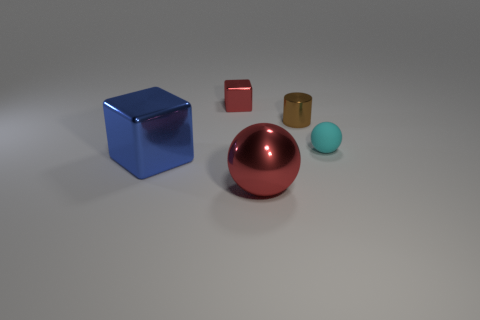There is a large blue metal object; is it the same shape as the red thing that is behind the cyan object?
Offer a terse response. Yes. There is a thing that is the same color as the metallic ball; what is its shape?
Offer a very short reply. Cube. Is the number of large blue blocks right of the big red ball less than the number of large cyan matte things?
Make the answer very short. No. Is the shape of the small matte thing the same as the big red object?
Your answer should be compact. Yes. The blue cube that is the same material as the big red object is what size?
Your response must be concise. Large. Are there fewer brown matte balls than large spheres?
Your answer should be compact. Yes. How many tiny things are green metallic cylinders or red metallic things?
Make the answer very short. 1. What number of shiny things are right of the red metallic cube and in front of the tiny cyan sphere?
Keep it short and to the point. 1. Are there more tiny brown cylinders than tiny purple cubes?
Ensure brevity in your answer.  Yes. What number of other things are the same shape as the large blue metal thing?
Ensure brevity in your answer.  1. 